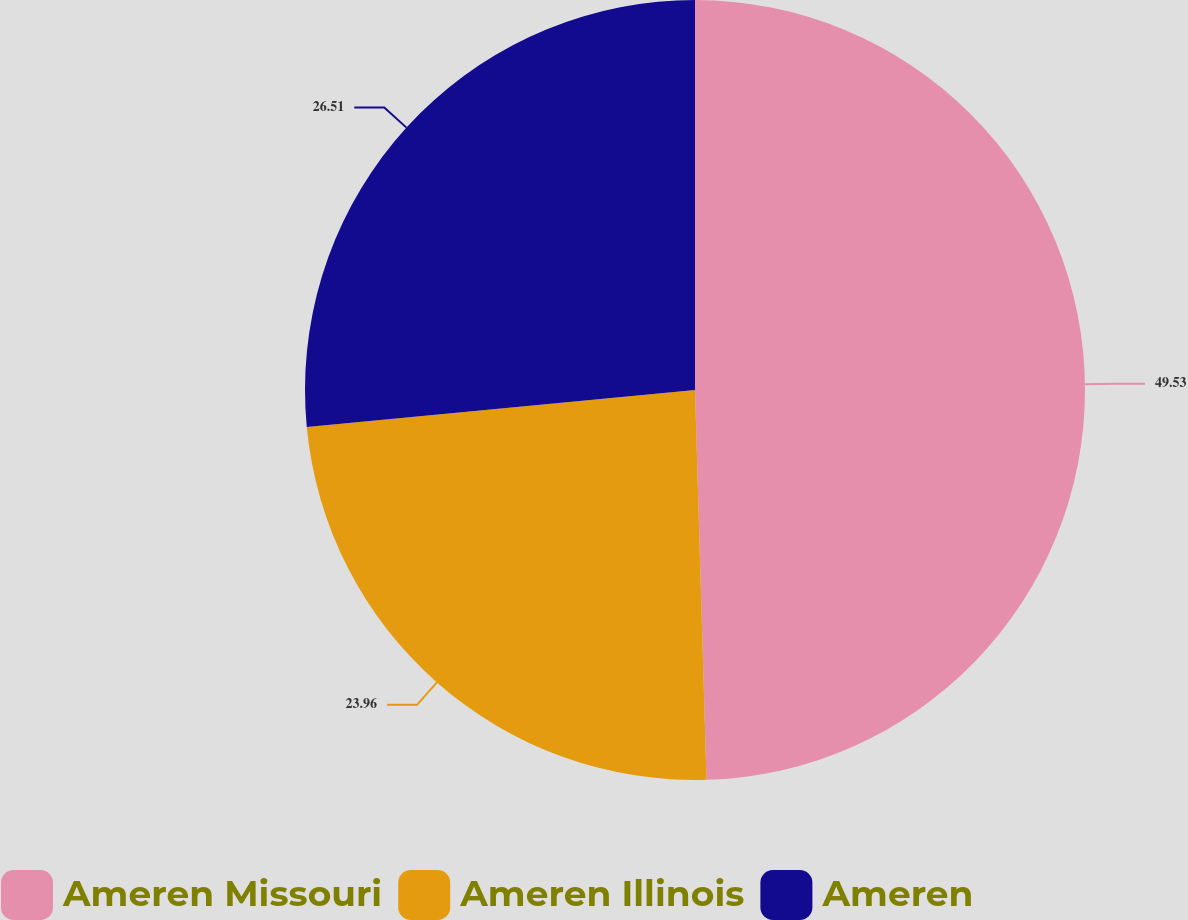Convert chart to OTSL. <chart><loc_0><loc_0><loc_500><loc_500><pie_chart><fcel>Ameren Missouri<fcel>Ameren Illinois<fcel>Ameren<nl><fcel>49.53%<fcel>23.96%<fcel>26.51%<nl></chart> 